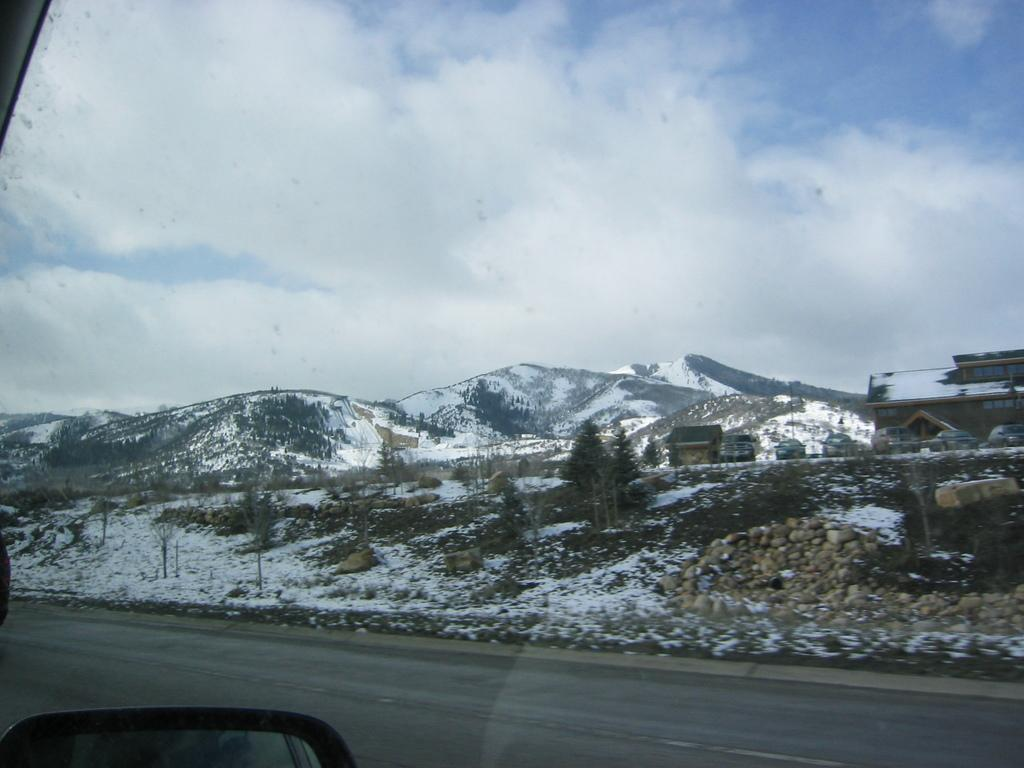What is the location of the image? The image is taken from a car outside. What type of surface can be seen on the ground in the image? The ground has a snow surface. What natural features are visible in the image? There are plants, trees, and hills with snow in the image. What is visible in the sky in the image? The sky is visible in the image, and clouds are present. What decision is being made by the volcano in the image? There is no volcano present in the image, so no decision can be made by it. How is the control of the snow managed in the image? The image is a photograph and does not depict any control over the snow; it simply shows the snowy landscape. 